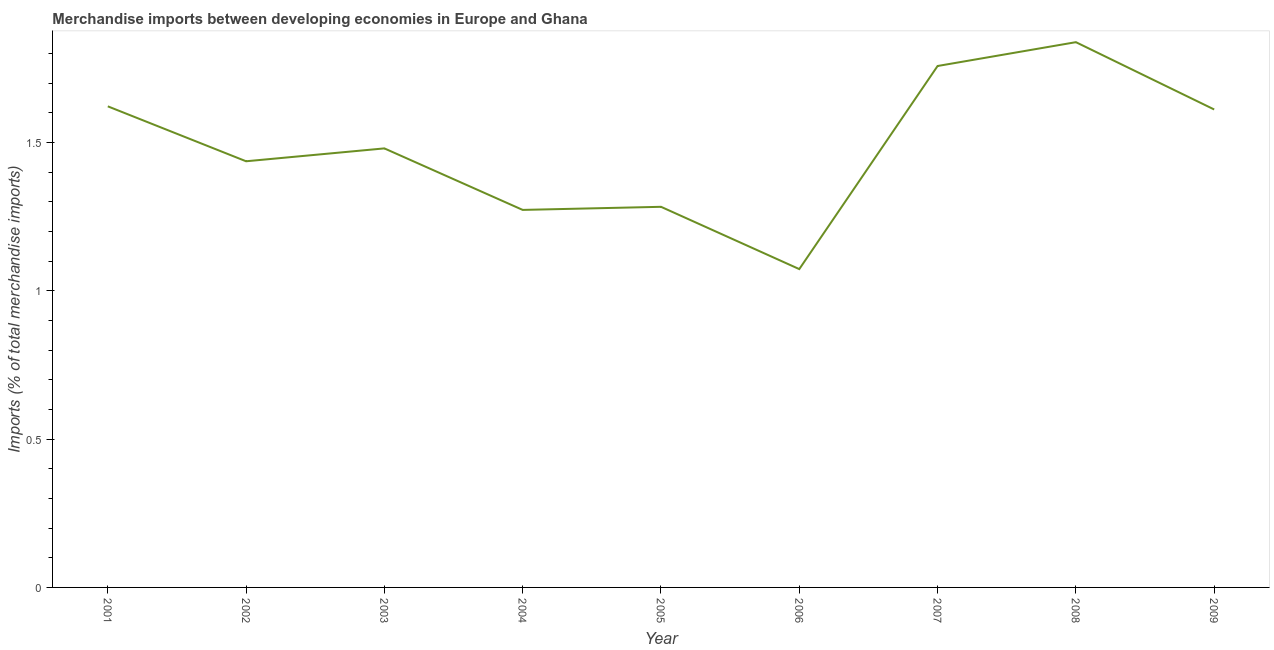What is the merchandise imports in 2003?
Make the answer very short. 1.48. Across all years, what is the maximum merchandise imports?
Provide a succinct answer. 1.84. Across all years, what is the minimum merchandise imports?
Your answer should be very brief. 1.07. In which year was the merchandise imports maximum?
Your answer should be very brief. 2008. What is the sum of the merchandise imports?
Offer a terse response. 13.38. What is the difference between the merchandise imports in 2008 and 2009?
Your response must be concise. 0.23. What is the average merchandise imports per year?
Give a very brief answer. 1.49. What is the median merchandise imports?
Offer a very short reply. 1.48. What is the ratio of the merchandise imports in 2001 to that in 2003?
Offer a terse response. 1.1. Is the difference between the merchandise imports in 2002 and 2006 greater than the difference between any two years?
Provide a succinct answer. No. What is the difference between the highest and the second highest merchandise imports?
Offer a terse response. 0.08. Is the sum of the merchandise imports in 2001 and 2009 greater than the maximum merchandise imports across all years?
Keep it short and to the point. Yes. What is the difference between the highest and the lowest merchandise imports?
Give a very brief answer. 0.77. In how many years, is the merchandise imports greater than the average merchandise imports taken over all years?
Provide a succinct answer. 4. How many lines are there?
Make the answer very short. 1. Does the graph contain any zero values?
Your answer should be very brief. No. What is the title of the graph?
Ensure brevity in your answer.  Merchandise imports between developing economies in Europe and Ghana. What is the label or title of the X-axis?
Offer a very short reply. Year. What is the label or title of the Y-axis?
Ensure brevity in your answer.  Imports (% of total merchandise imports). What is the Imports (% of total merchandise imports) of 2001?
Your answer should be very brief. 1.62. What is the Imports (% of total merchandise imports) of 2002?
Ensure brevity in your answer.  1.44. What is the Imports (% of total merchandise imports) of 2003?
Offer a very short reply. 1.48. What is the Imports (% of total merchandise imports) in 2004?
Keep it short and to the point. 1.27. What is the Imports (% of total merchandise imports) of 2005?
Make the answer very short. 1.28. What is the Imports (% of total merchandise imports) in 2006?
Make the answer very short. 1.07. What is the Imports (% of total merchandise imports) in 2007?
Make the answer very short. 1.76. What is the Imports (% of total merchandise imports) in 2008?
Make the answer very short. 1.84. What is the Imports (% of total merchandise imports) of 2009?
Provide a succinct answer. 1.61. What is the difference between the Imports (% of total merchandise imports) in 2001 and 2002?
Make the answer very short. 0.19. What is the difference between the Imports (% of total merchandise imports) in 2001 and 2003?
Make the answer very short. 0.14. What is the difference between the Imports (% of total merchandise imports) in 2001 and 2004?
Your answer should be very brief. 0.35. What is the difference between the Imports (% of total merchandise imports) in 2001 and 2005?
Your answer should be compact. 0.34. What is the difference between the Imports (% of total merchandise imports) in 2001 and 2006?
Your answer should be very brief. 0.55. What is the difference between the Imports (% of total merchandise imports) in 2001 and 2007?
Provide a succinct answer. -0.14. What is the difference between the Imports (% of total merchandise imports) in 2001 and 2008?
Offer a terse response. -0.22. What is the difference between the Imports (% of total merchandise imports) in 2001 and 2009?
Provide a succinct answer. 0.01. What is the difference between the Imports (% of total merchandise imports) in 2002 and 2003?
Offer a very short reply. -0.04. What is the difference between the Imports (% of total merchandise imports) in 2002 and 2004?
Your answer should be compact. 0.16. What is the difference between the Imports (% of total merchandise imports) in 2002 and 2005?
Provide a succinct answer. 0.15. What is the difference between the Imports (% of total merchandise imports) in 2002 and 2006?
Keep it short and to the point. 0.36. What is the difference between the Imports (% of total merchandise imports) in 2002 and 2007?
Provide a short and direct response. -0.32. What is the difference between the Imports (% of total merchandise imports) in 2002 and 2008?
Your response must be concise. -0.4. What is the difference between the Imports (% of total merchandise imports) in 2002 and 2009?
Keep it short and to the point. -0.17. What is the difference between the Imports (% of total merchandise imports) in 2003 and 2004?
Provide a succinct answer. 0.21. What is the difference between the Imports (% of total merchandise imports) in 2003 and 2005?
Ensure brevity in your answer.  0.2. What is the difference between the Imports (% of total merchandise imports) in 2003 and 2006?
Your answer should be compact. 0.41. What is the difference between the Imports (% of total merchandise imports) in 2003 and 2007?
Offer a very short reply. -0.28. What is the difference between the Imports (% of total merchandise imports) in 2003 and 2008?
Your answer should be very brief. -0.36. What is the difference between the Imports (% of total merchandise imports) in 2003 and 2009?
Make the answer very short. -0.13. What is the difference between the Imports (% of total merchandise imports) in 2004 and 2005?
Keep it short and to the point. -0.01. What is the difference between the Imports (% of total merchandise imports) in 2004 and 2006?
Your answer should be very brief. 0.2. What is the difference between the Imports (% of total merchandise imports) in 2004 and 2007?
Ensure brevity in your answer.  -0.49. What is the difference between the Imports (% of total merchandise imports) in 2004 and 2008?
Provide a succinct answer. -0.57. What is the difference between the Imports (% of total merchandise imports) in 2004 and 2009?
Your response must be concise. -0.34. What is the difference between the Imports (% of total merchandise imports) in 2005 and 2006?
Provide a succinct answer. 0.21. What is the difference between the Imports (% of total merchandise imports) in 2005 and 2007?
Ensure brevity in your answer.  -0.47. What is the difference between the Imports (% of total merchandise imports) in 2005 and 2008?
Keep it short and to the point. -0.56. What is the difference between the Imports (% of total merchandise imports) in 2005 and 2009?
Offer a very short reply. -0.33. What is the difference between the Imports (% of total merchandise imports) in 2006 and 2007?
Provide a succinct answer. -0.68. What is the difference between the Imports (% of total merchandise imports) in 2006 and 2008?
Offer a very short reply. -0.77. What is the difference between the Imports (% of total merchandise imports) in 2006 and 2009?
Provide a short and direct response. -0.54. What is the difference between the Imports (% of total merchandise imports) in 2007 and 2008?
Ensure brevity in your answer.  -0.08. What is the difference between the Imports (% of total merchandise imports) in 2007 and 2009?
Offer a very short reply. 0.15. What is the difference between the Imports (% of total merchandise imports) in 2008 and 2009?
Ensure brevity in your answer.  0.23. What is the ratio of the Imports (% of total merchandise imports) in 2001 to that in 2002?
Make the answer very short. 1.13. What is the ratio of the Imports (% of total merchandise imports) in 2001 to that in 2003?
Keep it short and to the point. 1.1. What is the ratio of the Imports (% of total merchandise imports) in 2001 to that in 2004?
Offer a very short reply. 1.27. What is the ratio of the Imports (% of total merchandise imports) in 2001 to that in 2005?
Provide a short and direct response. 1.26. What is the ratio of the Imports (% of total merchandise imports) in 2001 to that in 2006?
Make the answer very short. 1.51. What is the ratio of the Imports (% of total merchandise imports) in 2001 to that in 2007?
Offer a very short reply. 0.92. What is the ratio of the Imports (% of total merchandise imports) in 2001 to that in 2008?
Your answer should be compact. 0.88. What is the ratio of the Imports (% of total merchandise imports) in 2002 to that in 2004?
Make the answer very short. 1.13. What is the ratio of the Imports (% of total merchandise imports) in 2002 to that in 2005?
Your answer should be very brief. 1.12. What is the ratio of the Imports (% of total merchandise imports) in 2002 to that in 2006?
Ensure brevity in your answer.  1.34. What is the ratio of the Imports (% of total merchandise imports) in 2002 to that in 2007?
Your answer should be very brief. 0.82. What is the ratio of the Imports (% of total merchandise imports) in 2002 to that in 2008?
Your response must be concise. 0.78. What is the ratio of the Imports (% of total merchandise imports) in 2002 to that in 2009?
Offer a terse response. 0.89. What is the ratio of the Imports (% of total merchandise imports) in 2003 to that in 2004?
Offer a very short reply. 1.16. What is the ratio of the Imports (% of total merchandise imports) in 2003 to that in 2005?
Keep it short and to the point. 1.15. What is the ratio of the Imports (% of total merchandise imports) in 2003 to that in 2006?
Provide a short and direct response. 1.38. What is the ratio of the Imports (% of total merchandise imports) in 2003 to that in 2007?
Make the answer very short. 0.84. What is the ratio of the Imports (% of total merchandise imports) in 2003 to that in 2008?
Your answer should be compact. 0.81. What is the ratio of the Imports (% of total merchandise imports) in 2003 to that in 2009?
Provide a succinct answer. 0.92. What is the ratio of the Imports (% of total merchandise imports) in 2004 to that in 2005?
Offer a terse response. 0.99. What is the ratio of the Imports (% of total merchandise imports) in 2004 to that in 2006?
Offer a terse response. 1.19. What is the ratio of the Imports (% of total merchandise imports) in 2004 to that in 2007?
Provide a succinct answer. 0.72. What is the ratio of the Imports (% of total merchandise imports) in 2004 to that in 2008?
Offer a very short reply. 0.69. What is the ratio of the Imports (% of total merchandise imports) in 2004 to that in 2009?
Your answer should be compact. 0.79. What is the ratio of the Imports (% of total merchandise imports) in 2005 to that in 2006?
Offer a very short reply. 1.2. What is the ratio of the Imports (% of total merchandise imports) in 2005 to that in 2007?
Give a very brief answer. 0.73. What is the ratio of the Imports (% of total merchandise imports) in 2005 to that in 2008?
Make the answer very short. 0.7. What is the ratio of the Imports (% of total merchandise imports) in 2005 to that in 2009?
Your response must be concise. 0.8. What is the ratio of the Imports (% of total merchandise imports) in 2006 to that in 2007?
Your answer should be compact. 0.61. What is the ratio of the Imports (% of total merchandise imports) in 2006 to that in 2008?
Keep it short and to the point. 0.58. What is the ratio of the Imports (% of total merchandise imports) in 2006 to that in 2009?
Provide a succinct answer. 0.67. What is the ratio of the Imports (% of total merchandise imports) in 2007 to that in 2008?
Your answer should be very brief. 0.96. What is the ratio of the Imports (% of total merchandise imports) in 2007 to that in 2009?
Your response must be concise. 1.09. What is the ratio of the Imports (% of total merchandise imports) in 2008 to that in 2009?
Provide a short and direct response. 1.14. 